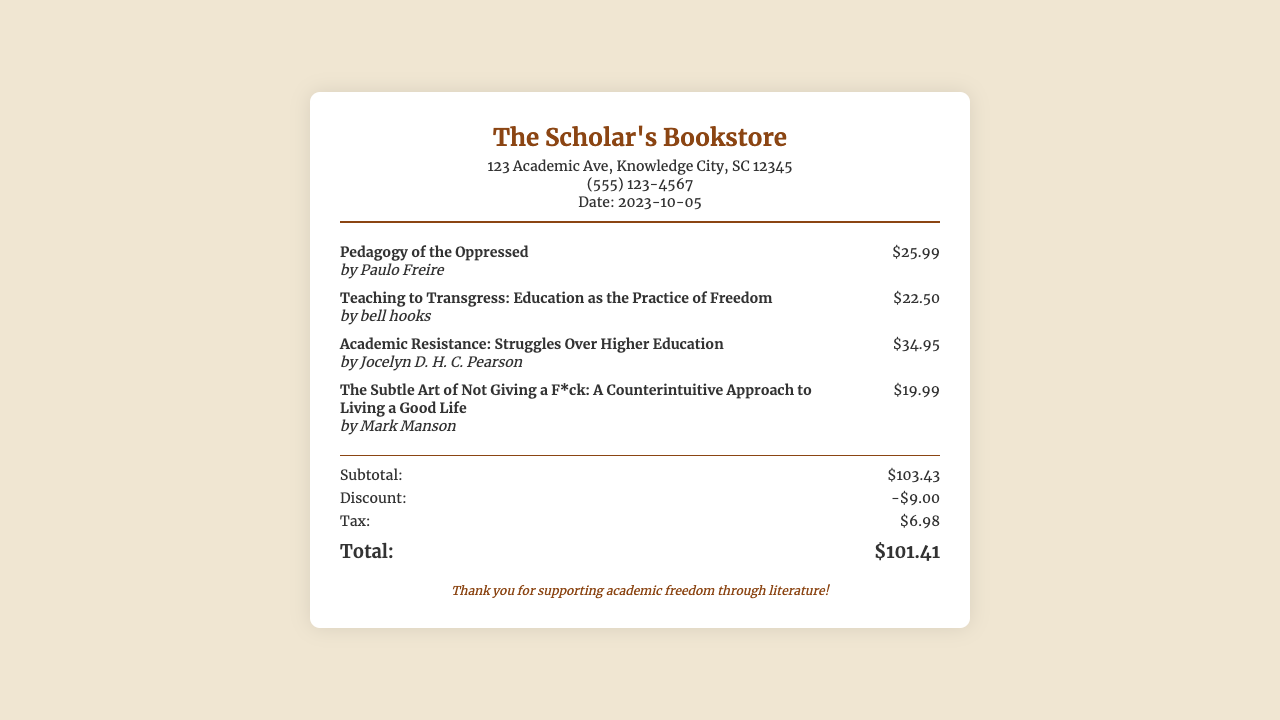What is the name of the bookstore? The name of the bookstore is displayed prominently at the top of the receipt.
Answer: The Scholar's Bookstore How many items were purchased? The receipt lists four individual items purchased.
Answer: 4 What is the total price before discount? The subtotal section shows the total price before any discounts are applied.
Answer: $103.43 What is the amount of the discount applied? The discount section specifies how much was deducted from the subtotal.
Answer: -$9.00 Who is the author of "Pedagogy of the Oppressed"? The author is mentioned below the title of the book on the receipt.
Answer: Paulo Freire What is the tax amount added to the total? The tax section shows the applied tax amount that is included in the total.
Answer: $6.98 What is the grand total on the receipt? The grand total is listed at the bottom of the totals section.
Answer: $101.41 What is the date of the purchase? The date indicates when the purchase was made and is located in the store info.
Answer: 2023-10-05 Which book has the highest price? The prices of each book can be compared to find the highest priced item.
Answer: Academic Resistance: Struggles Over Higher Education 